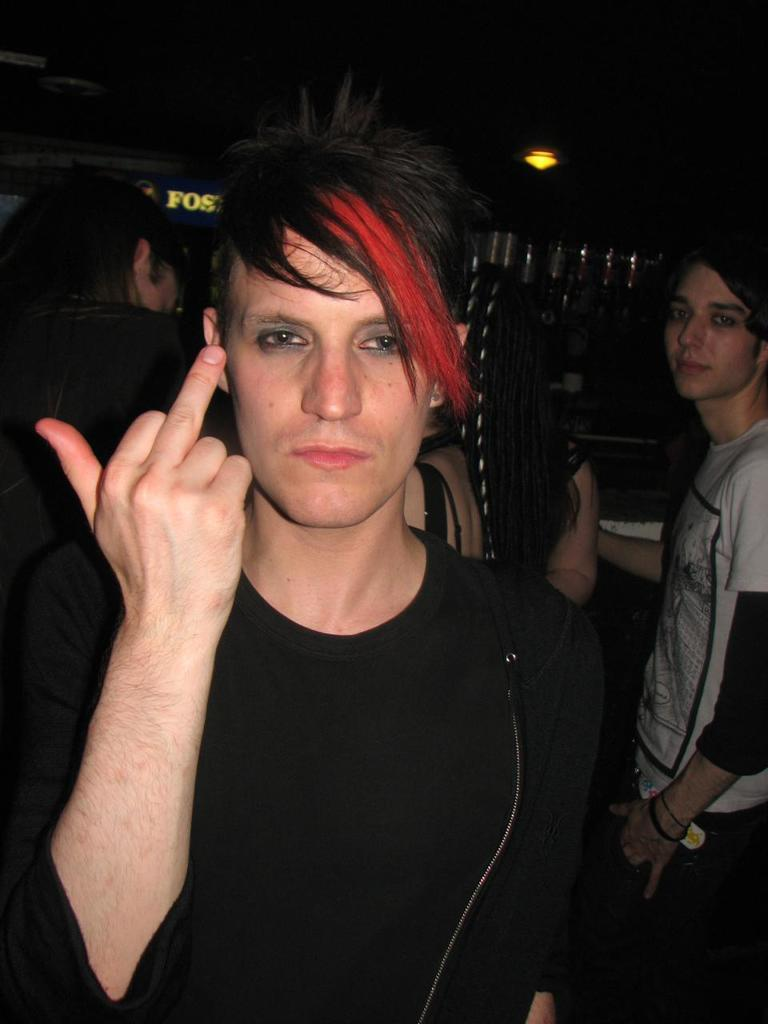What is the main subject in the foreground of the image? There is a man in the foreground of the image. What is the man doing in the image? The man is standing in the image. What is the man wearing in the image? The man is wearing a black t-shirt in the image. What can be observed about the man's hair color? The man has red hair in the image. What is visible in the background of the image? There are other people in the background of the image, and the background is dark. What type of knife is the man holding in the image? There is no knife present in the image; the man is not holding anything. How does the man express his feelings towards the other people in the image? The image does not provide any information about the man's feelings or emotions towards the other people. 